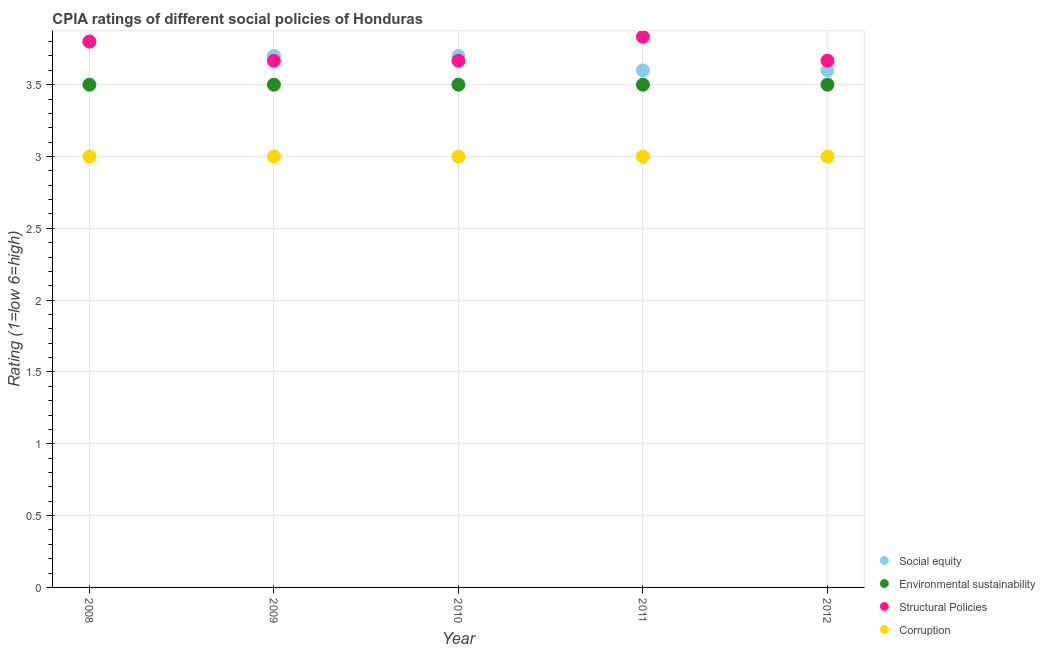What is the cpia rating of environmental sustainability in 2008?
Your answer should be very brief. 3.5. Across all years, what is the maximum cpia rating of corruption?
Offer a very short reply. 3. Across all years, what is the minimum cpia rating of environmental sustainability?
Keep it short and to the point. 3.5. In which year was the cpia rating of social equity maximum?
Keep it short and to the point. 2008. What is the total cpia rating of structural policies in the graph?
Your answer should be compact. 18.63. What is the difference between the cpia rating of corruption in 2008 and that in 2011?
Make the answer very short. 0. What is the difference between the cpia rating of environmental sustainability in 2012 and the cpia rating of corruption in 2009?
Keep it short and to the point. 0.5. What is the average cpia rating of structural policies per year?
Offer a very short reply. 3.73. In the year 2008, what is the difference between the cpia rating of corruption and cpia rating of structural policies?
Keep it short and to the point. -0.8. Is the cpia rating of structural policies in 2009 less than that in 2012?
Ensure brevity in your answer.  No. What is the difference between the highest and the second highest cpia rating of corruption?
Give a very brief answer. 0. What is the difference between the highest and the lowest cpia rating of social equity?
Ensure brevity in your answer.  0.2. In how many years, is the cpia rating of social equity greater than the average cpia rating of social equity taken over all years?
Offer a very short reply. 3. Is the sum of the cpia rating of structural policies in 2009 and 2010 greater than the maximum cpia rating of corruption across all years?
Make the answer very short. Yes. Is it the case that in every year, the sum of the cpia rating of social equity and cpia rating of structural policies is greater than the sum of cpia rating of corruption and cpia rating of environmental sustainability?
Your answer should be compact. No. Does the cpia rating of environmental sustainability monotonically increase over the years?
Offer a terse response. No. How many dotlines are there?
Ensure brevity in your answer.  4. What is the difference between two consecutive major ticks on the Y-axis?
Provide a short and direct response. 0.5. Are the values on the major ticks of Y-axis written in scientific E-notation?
Offer a very short reply. No. What is the title of the graph?
Offer a terse response. CPIA ratings of different social policies of Honduras. What is the label or title of the X-axis?
Keep it short and to the point. Year. What is the Rating (1=low 6=high) of Social equity in 2008?
Make the answer very short. 3.8. What is the Rating (1=low 6=high) of Structural Policies in 2008?
Your answer should be very brief. 3.8. What is the Rating (1=low 6=high) in Corruption in 2008?
Provide a succinct answer. 3. What is the Rating (1=low 6=high) in Environmental sustainability in 2009?
Your answer should be very brief. 3.5. What is the Rating (1=low 6=high) in Structural Policies in 2009?
Keep it short and to the point. 3.67. What is the Rating (1=low 6=high) of Social equity in 2010?
Make the answer very short. 3.7. What is the Rating (1=low 6=high) in Environmental sustainability in 2010?
Make the answer very short. 3.5. What is the Rating (1=low 6=high) of Structural Policies in 2010?
Keep it short and to the point. 3.67. What is the Rating (1=low 6=high) of Corruption in 2010?
Make the answer very short. 3. What is the Rating (1=low 6=high) in Environmental sustainability in 2011?
Keep it short and to the point. 3.5. What is the Rating (1=low 6=high) in Structural Policies in 2011?
Give a very brief answer. 3.83. What is the Rating (1=low 6=high) of Corruption in 2011?
Offer a terse response. 3. What is the Rating (1=low 6=high) in Social equity in 2012?
Your answer should be very brief. 3.6. What is the Rating (1=low 6=high) of Structural Policies in 2012?
Your response must be concise. 3.67. Across all years, what is the maximum Rating (1=low 6=high) in Social equity?
Offer a very short reply. 3.8. Across all years, what is the maximum Rating (1=low 6=high) in Environmental sustainability?
Make the answer very short. 3.5. Across all years, what is the maximum Rating (1=low 6=high) of Structural Policies?
Your response must be concise. 3.83. Across all years, what is the minimum Rating (1=low 6=high) in Social equity?
Your answer should be very brief. 3.6. Across all years, what is the minimum Rating (1=low 6=high) of Environmental sustainability?
Ensure brevity in your answer.  3.5. Across all years, what is the minimum Rating (1=low 6=high) in Structural Policies?
Your response must be concise. 3.67. Across all years, what is the minimum Rating (1=low 6=high) of Corruption?
Ensure brevity in your answer.  3. What is the total Rating (1=low 6=high) in Social equity in the graph?
Provide a short and direct response. 18.4. What is the total Rating (1=low 6=high) of Environmental sustainability in the graph?
Give a very brief answer. 17.5. What is the total Rating (1=low 6=high) of Structural Policies in the graph?
Ensure brevity in your answer.  18.63. What is the difference between the Rating (1=low 6=high) in Environmental sustainability in 2008 and that in 2009?
Ensure brevity in your answer.  0. What is the difference between the Rating (1=low 6=high) in Structural Policies in 2008 and that in 2009?
Give a very brief answer. 0.13. What is the difference between the Rating (1=low 6=high) in Corruption in 2008 and that in 2009?
Your response must be concise. 0. What is the difference between the Rating (1=low 6=high) in Environmental sustainability in 2008 and that in 2010?
Keep it short and to the point. 0. What is the difference between the Rating (1=low 6=high) in Structural Policies in 2008 and that in 2010?
Offer a terse response. 0.13. What is the difference between the Rating (1=low 6=high) in Corruption in 2008 and that in 2010?
Give a very brief answer. 0. What is the difference between the Rating (1=low 6=high) in Environmental sustainability in 2008 and that in 2011?
Your answer should be compact. 0. What is the difference between the Rating (1=low 6=high) of Structural Policies in 2008 and that in 2011?
Make the answer very short. -0.03. What is the difference between the Rating (1=low 6=high) in Corruption in 2008 and that in 2011?
Provide a short and direct response. 0. What is the difference between the Rating (1=low 6=high) in Social equity in 2008 and that in 2012?
Offer a terse response. 0.2. What is the difference between the Rating (1=low 6=high) in Environmental sustainability in 2008 and that in 2012?
Your response must be concise. 0. What is the difference between the Rating (1=low 6=high) in Structural Policies in 2008 and that in 2012?
Your response must be concise. 0.13. What is the difference between the Rating (1=low 6=high) in Structural Policies in 2009 and that in 2010?
Give a very brief answer. 0. What is the difference between the Rating (1=low 6=high) of Social equity in 2009 and that in 2011?
Keep it short and to the point. 0.1. What is the difference between the Rating (1=low 6=high) in Environmental sustainability in 2009 and that in 2011?
Provide a short and direct response. 0. What is the difference between the Rating (1=low 6=high) of Structural Policies in 2009 and that in 2011?
Give a very brief answer. -0.17. What is the difference between the Rating (1=low 6=high) of Corruption in 2009 and that in 2011?
Your answer should be compact. 0. What is the difference between the Rating (1=low 6=high) in Social equity in 2009 and that in 2012?
Your response must be concise. 0.1. What is the difference between the Rating (1=low 6=high) of Structural Policies in 2009 and that in 2012?
Your response must be concise. 0. What is the difference between the Rating (1=low 6=high) in Social equity in 2010 and that in 2011?
Provide a short and direct response. 0.1. What is the difference between the Rating (1=low 6=high) in Corruption in 2010 and that in 2011?
Make the answer very short. 0. What is the difference between the Rating (1=low 6=high) in Structural Policies in 2010 and that in 2012?
Keep it short and to the point. 0. What is the difference between the Rating (1=low 6=high) of Environmental sustainability in 2011 and that in 2012?
Make the answer very short. 0. What is the difference between the Rating (1=low 6=high) of Corruption in 2011 and that in 2012?
Your answer should be very brief. 0. What is the difference between the Rating (1=low 6=high) in Social equity in 2008 and the Rating (1=low 6=high) in Environmental sustainability in 2009?
Your answer should be compact. 0.3. What is the difference between the Rating (1=low 6=high) of Social equity in 2008 and the Rating (1=low 6=high) of Structural Policies in 2009?
Provide a succinct answer. 0.13. What is the difference between the Rating (1=low 6=high) of Social equity in 2008 and the Rating (1=low 6=high) of Corruption in 2009?
Your answer should be compact. 0.8. What is the difference between the Rating (1=low 6=high) of Environmental sustainability in 2008 and the Rating (1=low 6=high) of Corruption in 2009?
Offer a very short reply. 0.5. What is the difference between the Rating (1=low 6=high) of Structural Policies in 2008 and the Rating (1=low 6=high) of Corruption in 2009?
Offer a very short reply. 0.8. What is the difference between the Rating (1=low 6=high) in Social equity in 2008 and the Rating (1=low 6=high) in Environmental sustainability in 2010?
Ensure brevity in your answer.  0.3. What is the difference between the Rating (1=low 6=high) in Social equity in 2008 and the Rating (1=low 6=high) in Structural Policies in 2010?
Your response must be concise. 0.13. What is the difference between the Rating (1=low 6=high) of Environmental sustainability in 2008 and the Rating (1=low 6=high) of Structural Policies in 2010?
Provide a succinct answer. -0.17. What is the difference between the Rating (1=low 6=high) of Environmental sustainability in 2008 and the Rating (1=low 6=high) of Corruption in 2010?
Provide a short and direct response. 0.5. What is the difference between the Rating (1=low 6=high) of Social equity in 2008 and the Rating (1=low 6=high) of Environmental sustainability in 2011?
Give a very brief answer. 0.3. What is the difference between the Rating (1=low 6=high) of Social equity in 2008 and the Rating (1=low 6=high) of Structural Policies in 2011?
Your response must be concise. -0.03. What is the difference between the Rating (1=low 6=high) of Social equity in 2008 and the Rating (1=low 6=high) of Corruption in 2011?
Keep it short and to the point. 0.8. What is the difference between the Rating (1=low 6=high) of Environmental sustainability in 2008 and the Rating (1=low 6=high) of Structural Policies in 2011?
Provide a succinct answer. -0.33. What is the difference between the Rating (1=low 6=high) in Environmental sustainability in 2008 and the Rating (1=low 6=high) in Corruption in 2011?
Make the answer very short. 0.5. What is the difference between the Rating (1=low 6=high) in Structural Policies in 2008 and the Rating (1=low 6=high) in Corruption in 2011?
Give a very brief answer. 0.8. What is the difference between the Rating (1=low 6=high) in Social equity in 2008 and the Rating (1=low 6=high) in Environmental sustainability in 2012?
Offer a very short reply. 0.3. What is the difference between the Rating (1=low 6=high) of Social equity in 2008 and the Rating (1=low 6=high) of Structural Policies in 2012?
Your answer should be compact. 0.13. What is the difference between the Rating (1=low 6=high) in Social equity in 2008 and the Rating (1=low 6=high) in Corruption in 2012?
Your answer should be compact. 0.8. What is the difference between the Rating (1=low 6=high) in Environmental sustainability in 2008 and the Rating (1=low 6=high) in Structural Policies in 2012?
Ensure brevity in your answer.  -0.17. What is the difference between the Rating (1=low 6=high) of Environmental sustainability in 2008 and the Rating (1=low 6=high) of Corruption in 2012?
Give a very brief answer. 0.5. What is the difference between the Rating (1=low 6=high) in Structural Policies in 2008 and the Rating (1=low 6=high) in Corruption in 2012?
Offer a terse response. 0.8. What is the difference between the Rating (1=low 6=high) in Social equity in 2009 and the Rating (1=low 6=high) in Corruption in 2010?
Keep it short and to the point. 0.7. What is the difference between the Rating (1=low 6=high) of Environmental sustainability in 2009 and the Rating (1=low 6=high) of Corruption in 2010?
Your answer should be very brief. 0.5. What is the difference between the Rating (1=low 6=high) in Structural Policies in 2009 and the Rating (1=low 6=high) in Corruption in 2010?
Provide a succinct answer. 0.67. What is the difference between the Rating (1=low 6=high) of Social equity in 2009 and the Rating (1=low 6=high) of Structural Policies in 2011?
Offer a very short reply. -0.13. What is the difference between the Rating (1=low 6=high) in Structural Policies in 2009 and the Rating (1=low 6=high) in Corruption in 2011?
Make the answer very short. 0.67. What is the difference between the Rating (1=low 6=high) of Social equity in 2009 and the Rating (1=low 6=high) of Structural Policies in 2012?
Provide a succinct answer. 0.03. What is the difference between the Rating (1=low 6=high) of Social equity in 2010 and the Rating (1=low 6=high) of Structural Policies in 2011?
Give a very brief answer. -0.13. What is the difference between the Rating (1=low 6=high) of Social equity in 2010 and the Rating (1=low 6=high) of Corruption in 2011?
Give a very brief answer. 0.7. What is the difference between the Rating (1=low 6=high) of Environmental sustainability in 2010 and the Rating (1=low 6=high) of Structural Policies in 2011?
Offer a terse response. -0.33. What is the difference between the Rating (1=low 6=high) of Environmental sustainability in 2010 and the Rating (1=low 6=high) of Corruption in 2011?
Ensure brevity in your answer.  0.5. What is the difference between the Rating (1=low 6=high) of Social equity in 2010 and the Rating (1=low 6=high) of Environmental sustainability in 2012?
Provide a succinct answer. 0.2. What is the difference between the Rating (1=low 6=high) of Social equity in 2010 and the Rating (1=low 6=high) of Structural Policies in 2012?
Your answer should be compact. 0.03. What is the difference between the Rating (1=low 6=high) of Social equity in 2010 and the Rating (1=low 6=high) of Corruption in 2012?
Ensure brevity in your answer.  0.7. What is the difference between the Rating (1=low 6=high) in Structural Policies in 2010 and the Rating (1=low 6=high) in Corruption in 2012?
Your answer should be compact. 0.67. What is the difference between the Rating (1=low 6=high) of Social equity in 2011 and the Rating (1=low 6=high) of Environmental sustainability in 2012?
Provide a short and direct response. 0.1. What is the difference between the Rating (1=low 6=high) in Social equity in 2011 and the Rating (1=low 6=high) in Structural Policies in 2012?
Give a very brief answer. -0.07. What is the difference between the Rating (1=low 6=high) in Structural Policies in 2011 and the Rating (1=low 6=high) in Corruption in 2012?
Give a very brief answer. 0.83. What is the average Rating (1=low 6=high) of Social equity per year?
Give a very brief answer. 3.68. What is the average Rating (1=low 6=high) in Structural Policies per year?
Your answer should be compact. 3.73. In the year 2008, what is the difference between the Rating (1=low 6=high) in Social equity and Rating (1=low 6=high) in Environmental sustainability?
Offer a terse response. 0.3. In the year 2008, what is the difference between the Rating (1=low 6=high) in Social equity and Rating (1=low 6=high) in Corruption?
Provide a succinct answer. 0.8. In the year 2008, what is the difference between the Rating (1=low 6=high) in Environmental sustainability and Rating (1=low 6=high) in Structural Policies?
Offer a very short reply. -0.3. In the year 2008, what is the difference between the Rating (1=low 6=high) in Structural Policies and Rating (1=low 6=high) in Corruption?
Your answer should be very brief. 0.8. In the year 2009, what is the difference between the Rating (1=low 6=high) of Social equity and Rating (1=low 6=high) of Environmental sustainability?
Your response must be concise. 0.2. In the year 2009, what is the difference between the Rating (1=low 6=high) of Social equity and Rating (1=low 6=high) of Structural Policies?
Your response must be concise. 0.03. In the year 2009, what is the difference between the Rating (1=low 6=high) in Social equity and Rating (1=low 6=high) in Corruption?
Your answer should be very brief. 0.7. In the year 2009, what is the difference between the Rating (1=low 6=high) in Environmental sustainability and Rating (1=low 6=high) in Corruption?
Ensure brevity in your answer.  0.5. In the year 2010, what is the difference between the Rating (1=low 6=high) in Social equity and Rating (1=low 6=high) in Environmental sustainability?
Provide a short and direct response. 0.2. In the year 2010, what is the difference between the Rating (1=low 6=high) of Social equity and Rating (1=low 6=high) of Corruption?
Your answer should be very brief. 0.7. In the year 2010, what is the difference between the Rating (1=low 6=high) in Environmental sustainability and Rating (1=low 6=high) in Structural Policies?
Your response must be concise. -0.17. In the year 2010, what is the difference between the Rating (1=low 6=high) in Environmental sustainability and Rating (1=low 6=high) in Corruption?
Make the answer very short. 0.5. In the year 2010, what is the difference between the Rating (1=low 6=high) of Structural Policies and Rating (1=low 6=high) of Corruption?
Keep it short and to the point. 0.67. In the year 2011, what is the difference between the Rating (1=low 6=high) in Social equity and Rating (1=low 6=high) in Environmental sustainability?
Your response must be concise. 0.1. In the year 2011, what is the difference between the Rating (1=low 6=high) of Social equity and Rating (1=low 6=high) of Structural Policies?
Ensure brevity in your answer.  -0.23. In the year 2011, what is the difference between the Rating (1=low 6=high) of Social equity and Rating (1=low 6=high) of Corruption?
Make the answer very short. 0.6. In the year 2011, what is the difference between the Rating (1=low 6=high) of Environmental sustainability and Rating (1=low 6=high) of Structural Policies?
Ensure brevity in your answer.  -0.33. In the year 2011, what is the difference between the Rating (1=low 6=high) in Environmental sustainability and Rating (1=low 6=high) in Corruption?
Your response must be concise. 0.5. In the year 2011, what is the difference between the Rating (1=low 6=high) in Structural Policies and Rating (1=low 6=high) in Corruption?
Provide a short and direct response. 0.83. In the year 2012, what is the difference between the Rating (1=low 6=high) of Social equity and Rating (1=low 6=high) of Structural Policies?
Ensure brevity in your answer.  -0.07. What is the ratio of the Rating (1=low 6=high) of Social equity in 2008 to that in 2009?
Keep it short and to the point. 1.03. What is the ratio of the Rating (1=low 6=high) in Structural Policies in 2008 to that in 2009?
Your answer should be compact. 1.04. What is the ratio of the Rating (1=low 6=high) of Corruption in 2008 to that in 2009?
Ensure brevity in your answer.  1. What is the ratio of the Rating (1=low 6=high) in Social equity in 2008 to that in 2010?
Your answer should be very brief. 1.03. What is the ratio of the Rating (1=low 6=high) of Environmental sustainability in 2008 to that in 2010?
Ensure brevity in your answer.  1. What is the ratio of the Rating (1=low 6=high) in Structural Policies in 2008 to that in 2010?
Give a very brief answer. 1.04. What is the ratio of the Rating (1=low 6=high) in Social equity in 2008 to that in 2011?
Make the answer very short. 1.06. What is the ratio of the Rating (1=low 6=high) in Environmental sustainability in 2008 to that in 2011?
Provide a succinct answer. 1. What is the ratio of the Rating (1=low 6=high) in Structural Policies in 2008 to that in 2011?
Provide a short and direct response. 0.99. What is the ratio of the Rating (1=low 6=high) of Social equity in 2008 to that in 2012?
Provide a succinct answer. 1.06. What is the ratio of the Rating (1=low 6=high) of Structural Policies in 2008 to that in 2012?
Your answer should be very brief. 1.04. What is the ratio of the Rating (1=low 6=high) in Environmental sustainability in 2009 to that in 2010?
Offer a terse response. 1. What is the ratio of the Rating (1=low 6=high) of Structural Policies in 2009 to that in 2010?
Provide a short and direct response. 1. What is the ratio of the Rating (1=low 6=high) of Corruption in 2009 to that in 2010?
Offer a very short reply. 1. What is the ratio of the Rating (1=low 6=high) of Social equity in 2009 to that in 2011?
Make the answer very short. 1.03. What is the ratio of the Rating (1=low 6=high) in Structural Policies in 2009 to that in 2011?
Ensure brevity in your answer.  0.96. What is the ratio of the Rating (1=low 6=high) of Corruption in 2009 to that in 2011?
Offer a very short reply. 1. What is the ratio of the Rating (1=low 6=high) of Social equity in 2009 to that in 2012?
Offer a very short reply. 1.03. What is the ratio of the Rating (1=low 6=high) of Environmental sustainability in 2009 to that in 2012?
Provide a short and direct response. 1. What is the ratio of the Rating (1=low 6=high) of Structural Policies in 2009 to that in 2012?
Keep it short and to the point. 1. What is the ratio of the Rating (1=low 6=high) of Corruption in 2009 to that in 2012?
Your answer should be compact. 1. What is the ratio of the Rating (1=low 6=high) in Social equity in 2010 to that in 2011?
Your answer should be very brief. 1.03. What is the ratio of the Rating (1=low 6=high) of Structural Policies in 2010 to that in 2011?
Give a very brief answer. 0.96. What is the ratio of the Rating (1=low 6=high) in Social equity in 2010 to that in 2012?
Make the answer very short. 1.03. What is the ratio of the Rating (1=low 6=high) in Structural Policies in 2010 to that in 2012?
Ensure brevity in your answer.  1. What is the ratio of the Rating (1=low 6=high) of Corruption in 2010 to that in 2012?
Give a very brief answer. 1. What is the ratio of the Rating (1=low 6=high) in Social equity in 2011 to that in 2012?
Offer a terse response. 1. What is the ratio of the Rating (1=low 6=high) of Environmental sustainability in 2011 to that in 2012?
Keep it short and to the point. 1. What is the ratio of the Rating (1=low 6=high) of Structural Policies in 2011 to that in 2012?
Your answer should be very brief. 1.05. What is the ratio of the Rating (1=low 6=high) of Corruption in 2011 to that in 2012?
Your answer should be very brief. 1. What is the difference between the highest and the second highest Rating (1=low 6=high) in Social equity?
Your answer should be compact. 0.1. What is the difference between the highest and the second highest Rating (1=low 6=high) of Environmental sustainability?
Provide a succinct answer. 0. What is the difference between the highest and the second highest Rating (1=low 6=high) in Structural Policies?
Give a very brief answer. 0.03. What is the difference between the highest and the lowest Rating (1=low 6=high) in Social equity?
Make the answer very short. 0.2. What is the difference between the highest and the lowest Rating (1=low 6=high) of Structural Policies?
Your response must be concise. 0.17. What is the difference between the highest and the lowest Rating (1=low 6=high) in Corruption?
Provide a succinct answer. 0. 